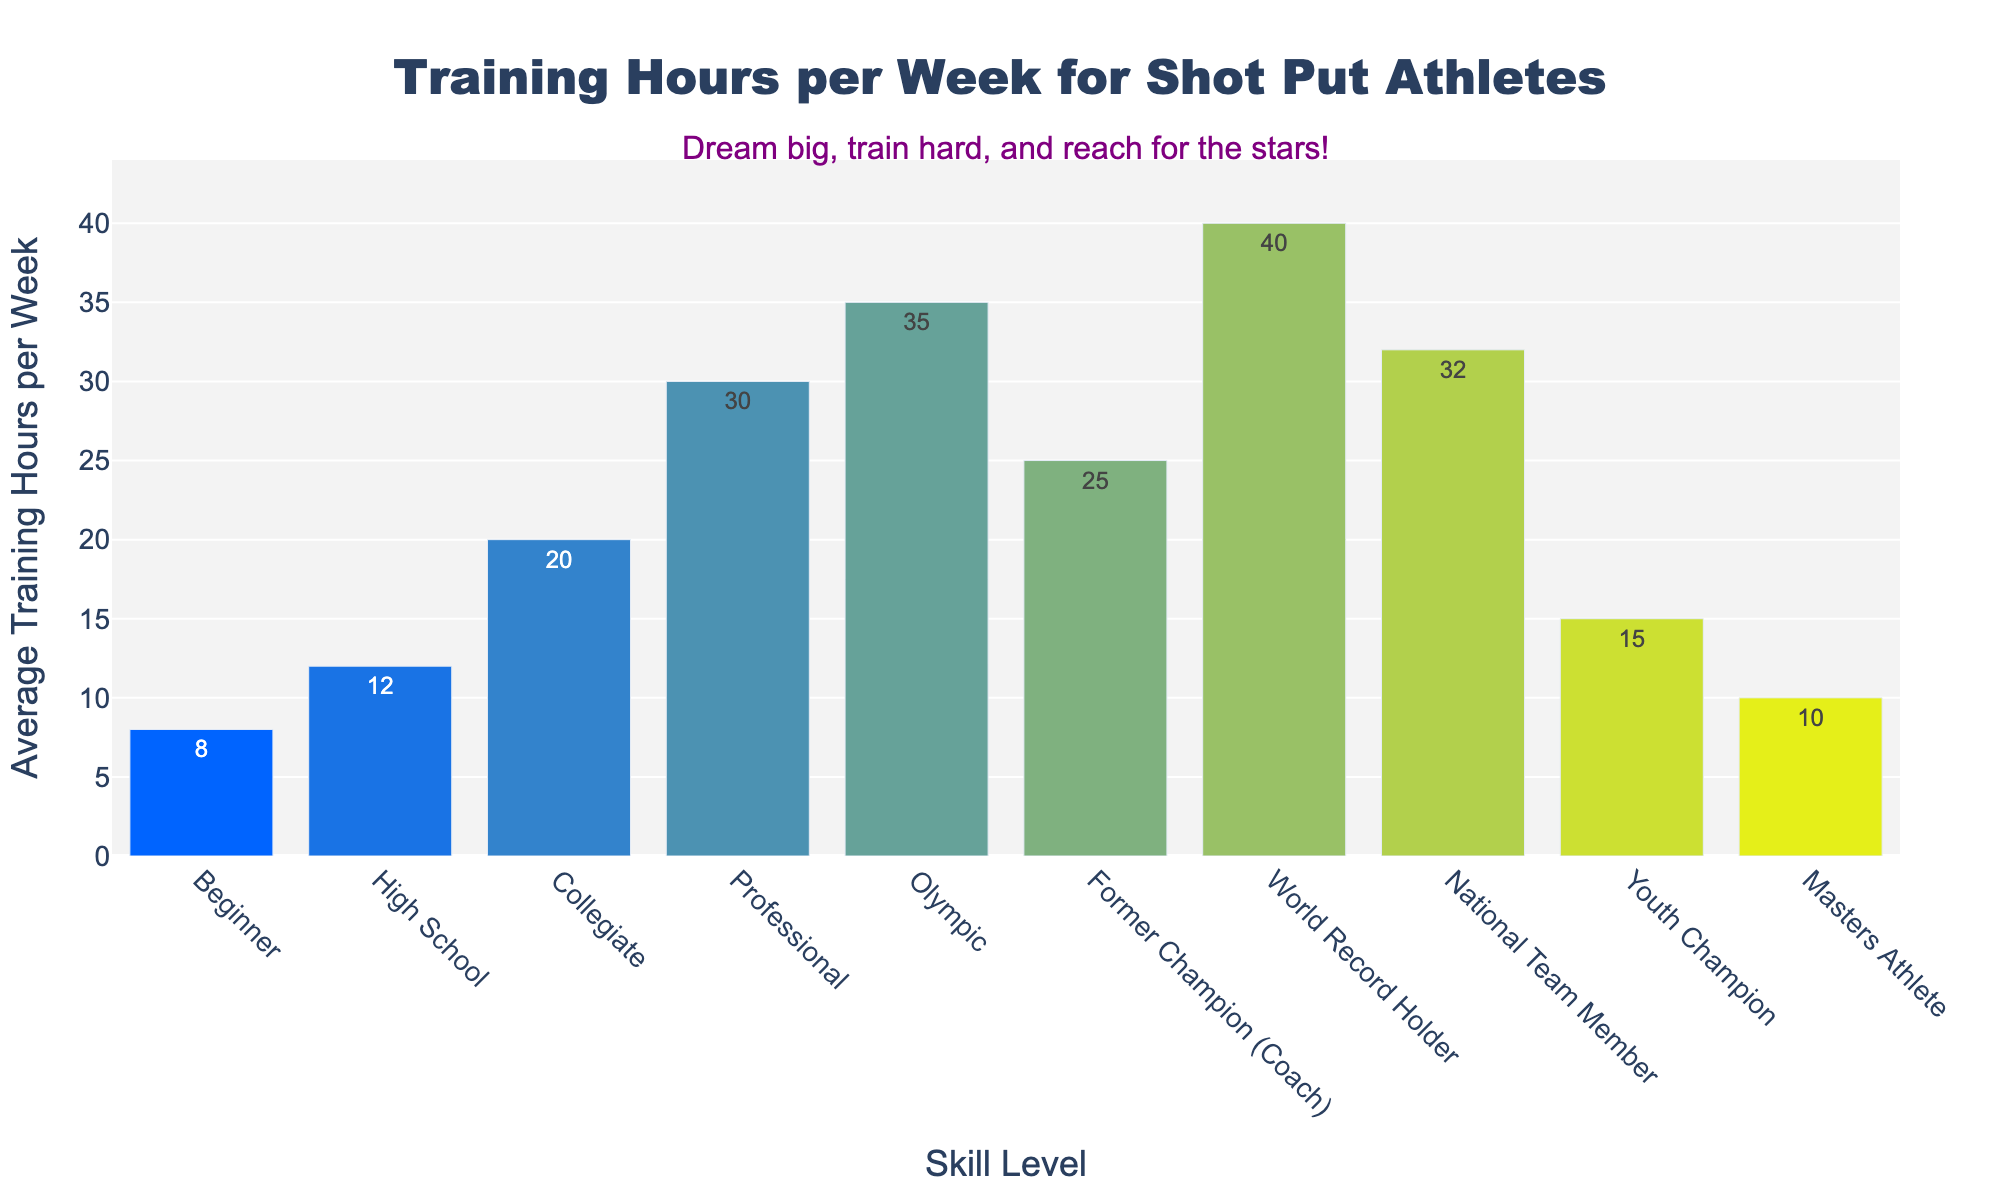What's the average training hours per week for professional and collegiate athletes? The training hours per week for professional athletes are 30, and for collegiate athletes are 20. To find the average, add 30 and 20, then divide by 2: (30 + 20) / 2 = 25.
Answer: 25 Which skill level trains the most hours per week? By looking at the height of the bars and their corresponding labels, the World Record Holder has the highest bar with 40 hours per week.
Answer: World Record Holder How many more hours per week does an Olympic-level athlete train compared to a high school athlete? Olympic athletes train 35 hours per week while high school athletes train 12 hours per week. The difference is 35 - 12 = 23 hours.
Answer: 23 How many skill levels train more than 20 hours per week? By checking each skill level bar against the 20-hour mark, those above it include Collegiate, Professional, Olympic, Former Champion (Coach), National Team Member, and World Record Holder. There are 6 such skill levels.
Answer: 6 Compare the average training hours of former champions (coaches) and youth champions. Who trains more, and by how many hours? Former Champion (Coach) trains 25 hours per week and Youth Champion trains 15 hours per week. The difference is 25 - 15 = 10 hours.
Answer: Former Champion (Coach) by 10 hours 